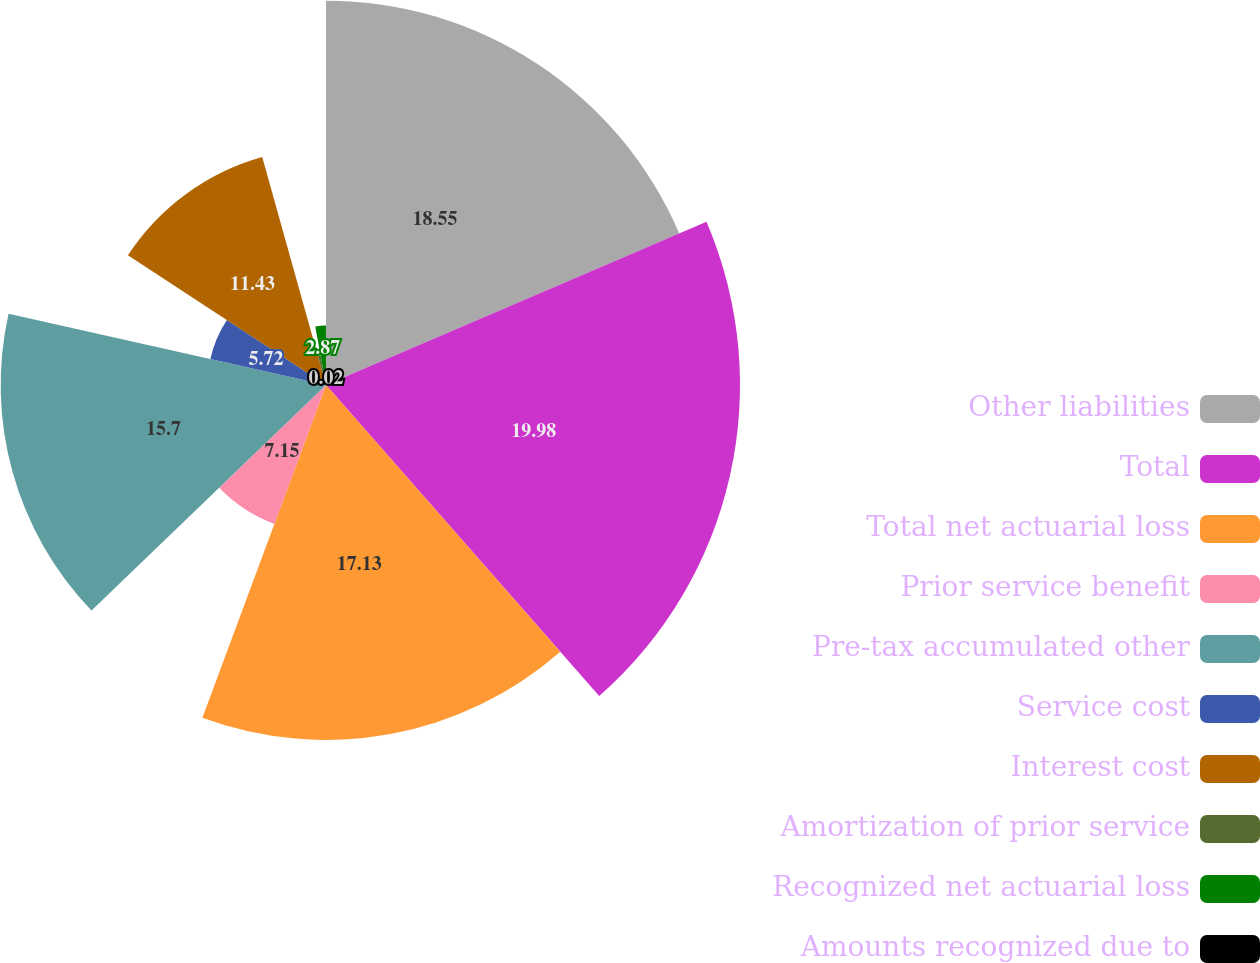<chart> <loc_0><loc_0><loc_500><loc_500><pie_chart><fcel>Other liabilities<fcel>Total<fcel>Total net actuarial loss<fcel>Prior service benefit<fcel>Pre-tax accumulated other<fcel>Service cost<fcel>Interest cost<fcel>Amortization of prior service<fcel>Recognized net actuarial loss<fcel>Amounts recognized due to<nl><fcel>18.55%<fcel>19.98%<fcel>17.13%<fcel>7.15%<fcel>15.7%<fcel>5.72%<fcel>11.43%<fcel>1.45%<fcel>2.87%<fcel>0.02%<nl></chart> 